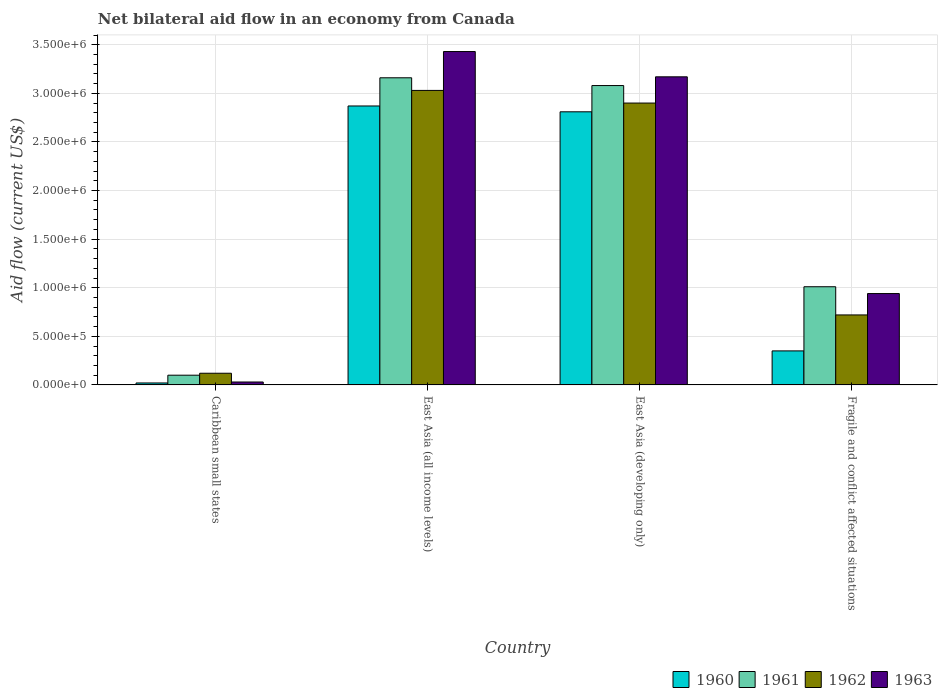How many groups of bars are there?
Offer a very short reply. 4. Are the number of bars per tick equal to the number of legend labels?
Make the answer very short. Yes. Are the number of bars on each tick of the X-axis equal?
Your answer should be compact. Yes. What is the label of the 2nd group of bars from the left?
Keep it short and to the point. East Asia (all income levels). What is the net bilateral aid flow in 1961 in East Asia (all income levels)?
Keep it short and to the point. 3.16e+06. Across all countries, what is the maximum net bilateral aid flow in 1963?
Your answer should be compact. 3.43e+06. Across all countries, what is the minimum net bilateral aid flow in 1963?
Your answer should be compact. 3.00e+04. In which country was the net bilateral aid flow in 1962 maximum?
Offer a very short reply. East Asia (all income levels). In which country was the net bilateral aid flow in 1963 minimum?
Offer a terse response. Caribbean small states. What is the total net bilateral aid flow in 1960 in the graph?
Ensure brevity in your answer.  6.05e+06. What is the difference between the net bilateral aid flow in 1961 in East Asia (all income levels) and that in Fragile and conflict affected situations?
Provide a short and direct response. 2.15e+06. What is the average net bilateral aid flow in 1962 per country?
Offer a very short reply. 1.69e+06. What is the difference between the net bilateral aid flow of/in 1963 and net bilateral aid flow of/in 1962 in Caribbean small states?
Your answer should be very brief. -9.00e+04. In how many countries, is the net bilateral aid flow in 1963 greater than 2400000 US$?
Keep it short and to the point. 2. What is the ratio of the net bilateral aid flow in 1960 in Caribbean small states to that in East Asia (developing only)?
Offer a very short reply. 0.01. Is the net bilateral aid flow in 1962 in Caribbean small states less than that in East Asia (all income levels)?
Provide a short and direct response. Yes. What is the difference between the highest and the second highest net bilateral aid flow in 1963?
Provide a succinct answer. 2.49e+06. What is the difference between the highest and the lowest net bilateral aid flow in 1960?
Make the answer very short. 2.85e+06. In how many countries, is the net bilateral aid flow in 1961 greater than the average net bilateral aid flow in 1961 taken over all countries?
Your answer should be very brief. 2. Is the sum of the net bilateral aid flow in 1961 in Caribbean small states and Fragile and conflict affected situations greater than the maximum net bilateral aid flow in 1962 across all countries?
Your answer should be very brief. No. Is it the case that in every country, the sum of the net bilateral aid flow in 1961 and net bilateral aid flow in 1962 is greater than the sum of net bilateral aid flow in 1960 and net bilateral aid flow in 1963?
Offer a terse response. No. What does the 3rd bar from the left in Caribbean small states represents?
Offer a terse response. 1962. What does the 1st bar from the right in Caribbean small states represents?
Offer a very short reply. 1963. How many bars are there?
Offer a terse response. 16. Are all the bars in the graph horizontal?
Give a very brief answer. No. How many countries are there in the graph?
Keep it short and to the point. 4. What is the difference between two consecutive major ticks on the Y-axis?
Offer a terse response. 5.00e+05. Does the graph contain any zero values?
Offer a terse response. No. Does the graph contain grids?
Ensure brevity in your answer.  Yes. Where does the legend appear in the graph?
Your answer should be compact. Bottom right. How are the legend labels stacked?
Your answer should be very brief. Horizontal. What is the title of the graph?
Keep it short and to the point. Net bilateral aid flow in an economy from Canada. What is the label or title of the X-axis?
Give a very brief answer. Country. What is the Aid flow (current US$) of 1961 in Caribbean small states?
Ensure brevity in your answer.  1.00e+05. What is the Aid flow (current US$) in 1960 in East Asia (all income levels)?
Give a very brief answer. 2.87e+06. What is the Aid flow (current US$) of 1961 in East Asia (all income levels)?
Your answer should be very brief. 3.16e+06. What is the Aid flow (current US$) in 1962 in East Asia (all income levels)?
Ensure brevity in your answer.  3.03e+06. What is the Aid flow (current US$) of 1963 in East Asia (all income levels)?
Your answer should be very brief. 3.43e+06. What is the Aid flow (current US$) in 1960 in East Asia (developing only)?
Offer a very short reply. 2.81e+06. What is the Aid flow (current US$) of 1961 in East Asia (developing only)?
Your response must be concise. 3.08e+06. What is the Aid flow (current US$) in 1962 in East Asia (developing only)?
Offer a very short reply. 2.90e+06. What is the Aid flow (current US$) of 1963 in East Asia (developing only)?
Make the answer very short. 3.17e+06. What is the Aid flow (current US$) of 1960 in Fragile and conflict affected situations?
Offer a very short reply. 3.50e+05. What is the Aid flow (current US$) in 1961 in Fragile and conflict affected situations?
Your answer should be compact. 1.01e+06. What is the Aid flow (current US$) of 1962 in Fragile and conflict affected situations?
Ensure brevity in your answer.  7.20e+05. What is the Aid flow (current US$) of 1963 in Fragile and conflict affected situations?
Keep it short and to the point. 9.40e+05. Across all countries, what is the maximum Aid flow (current US$) in 1960?
Your response must be concise. 2.87e+06. Across all countries, what is the maximum Aid flow (current US$) of 1961?
Offer a terse response. 3.16e+06. Across all countries, what is the maximum Aid flow (current US$) of 1962?
Your answer should be very brief. 3.03e+06. Across all countries, what is the maximum Aid flow (current US$) of 1963?
Offer a very short reply. 3.43e+06. Across all countries, what is the minimum Aid flow (current US$) in 1961?
Your response must be concise. 1.00e+05. Across all countries, what is the minimum Aid flow (current US$) of 1962?
Your response must be concise. 1.20e+05. Across all countries, what is the minimum Aid flow (current US$) in 1963?
Offer a very short reply. 3.00e+04. What is the total Aid flow (current US$) in 1960 in the graph?
Offer a very short reply. 6.05e+06. What is the total Aid flow (current US$) in 1961 in the graph?
Make the answer very short. 7.35e+06. What is the total Aid flow (current US$) in 1962 in the graph?
Give a very brief answer. 6.77e+06. What is the total Aid flow (current US$) in 1963 in the graph?
Make the answer very short. 7.57e+06. What is the difference between the Aid flow (current US$) in 1960 in Caribbean small states and that in East Asia (all income levels)?
Provide a short and direct response. -2.85e+06. What is the difference between the Aid flow (current US$) of 1961 in Caribbean small states and that in East Asia (all income levels)?
Keep it short and to the point. -3.06e+06. What is the difference between the Aid flow (current US$) of 1962 in Caribbean small states and that in East Asia (all income levels)?
Give a very brief answer. -2.91e+06. What is the difference between the Aid flow (current US$) in 1963 in Caribbean small states and that in East Asia (all income levels)?
Offer a terse response. -3.40e+06. What is the difference between the Aid flow (current US$) of 1960 in Caribbean small states and that in East Asia (developing only)?
Your answer should be very brief. -2.79e+06. What is the difference between the Aid flow (current US$) of 1961 in Caribbean small states and that in East Asia (developing only)?
Offer a terse response. -2.98e+06. What is the difference between the Aid flow (current US$) of 1962 in Caribbean small states and that in East Asia (developing only)?
Ensure brevity in your answer.  -2.78e+06. What is the difference between the Aid flow (current US$) in 1963 in Caribbean small states and that in East Asia (developing only)?
Make the answer very short. -3.14e+06. What is the difference between the Aid flow (current US$) in 1960 in Caribbean small states and that in Fragile and conflict affected situations?
Ensure brevity in your answer.  -3.30e+05. What is the difference between the Aid flow (current US$) in 1961 in Caribbean small states and that in Fragile and conflict affected situations?
Offer a very short reply. -9.10e+05. What is the difference between the Aid flow (current US$) in 1962 in Caribbean small states and that in Fragile and conflict affected situations?
Ensure brevity in your answer.  -6.00e+05. What is the difference between the Aid flow (current US$) of 1963 in Caribbean small states and that in Fragile and conflict affected situations?
Offer a terse response. -9.10e+05. What is the difference between the Aid flow (current US$) of 1962 in East Asia (all income levels) and that in East Asia (developing only)?
Ensure brevity in your answer.  1.30e+05. What is the difference between the Aid flow (current US$) of 1963 in East Asia (all income levels) and that in East Asia (developing only)?
Give a very brief answer. 2.60e+05. What is the difference between the Aid flow (current US$) of 1960 in East Asia (all income levels) and that in Fragile and conflict affected situations?
Offer a very short reply. 2.52e+06. What is the difference between the Aid flow (current US$) of 1961 in East Asia (all income levels) and that in Fragile and conflict affected situations?
Provide a succinct answer. 2.15e+06. What is the difference between the Aid flow (current US$) in 1962 in East Asia (all income levels) and that in Fragile and conflict affected situations?
Your answer should be very brief. 2.31e+06. What is the difference between the Aid flow (current US$) in 1963 in East Asia (all income levels) and that in Fragile and conflict affected situations?
Give a very brief answer. 2.49e+06. What is the difference between the Aid flow (current US$) in 1960 in East Asia (developing only) and that in Fragile and conflict affected situations?
Your response must be concise. 2.46e+06. What is the difference between the Aid flow (current US$) in 1961 in East Asia (developing only) and that in Fragile and conflict affected situations?
Ensure brevity in your answer.  2.07e+06. What is the difference between the Aid flow (current US$) of 1962 in East Asia (developing only) and that in Fragile and conflict affected situations?
Provide a succinct answer. 2.18e+06. What is the difference between the Aid flow (current US$) in 1963 in East Asia (developing only) and that in Fragile and conflict affected situations?
Your answer should be very brief. 2.23e+06. What is the difference between the Aid flow (current US$) of 1960 in Caribbean small states and the Aid flow (current US$) of 1961 in East Asia (all income levels)?
Provide a short and direct response. -3.14e+06. What is the difference between the Aid flow (current US$) of 1960 in Caribbean small states and the Aid flow (current US$) of 1962 in East Asia (all income levels)?
Offer a very short reply. -3.01e+06. What is the difference between the Aid flow (current US$) of 1960 in Caribbean small states and the Aid flow (current US$) of 1963 in East Asia (all income levels)?
Offer a terse response. -3.41e+06. What is the difference between the Aid flow (current US$) of 1961 in Caribbean small states and the Aid flow (current US$) of 1962 in East Asia (all income levels)?
Provide a short and direct response. -2.93e+06. What is the difference between the Aid flow (current US$) in 1961 in Caribbean small states and the Aid flow (current US$) in 1963 in East Asia (all income levels)?
Make the answer very short. -3.33e+06. What is the difference between the Aid flow (current US$) of 1962 in Caribbean small states and the Aid flow (current US$) of 1963 in East Asia (all income levels)?
Offer a very short reply. -3.31e+06. What is the difference between the Aid flow (current US$) of 1960 in Caribbean small states and the Aid flow (current US$) of 1961 in East Asia (developing only)?
Make the answer very short. -3.06e+06. What is the difference between the Aid flow (current US$) of 1960 in Caribbean small states and the Aid flow (current US$) of 1962 in East Asia (developing only)?
Make the answer very short. -2.88e+06. What is the difference between the Aid flow (current US$) in 1960 in Caribbean small states and the Aid flow (current US$) in 1963 in East Asia (developing only)?
Offer a terse response. -3.15e+06. What is the difference between the Aid flow (current US$) in 1961 in Caribbean small states and the Aid flow (current US$) in 1962 in East Asia (developing only)?
Your response must be concise. -2.80e+06. What is the difference between the Aid flow (current US$) of 1961 in Caribbean small states and the Aid flow (current US$) of 1963 in East Asia (developing only)?
Ensure brevity in your answer.  -3.07e+06. What is the difference between the Aid flow (current US$) of 1962 in Caribbean small states and the Aid flow (current US$) of 1963 in East Asia (developing only)?
Offer a terse response. -3.05e+06. What is the difference between the Aid flow (current US$) of 1960 in Caribbean small states and the Aid flow (current US$) of 1961 in Fragile and conflict affected situations?
Your answer should be very brief. -9.90e+05. What is the difference between the Aid flow (current US$) in 1960 in Caribbean small states and the Aid flow (current US$) in 1962 in Fragile and conflict affected situations?
Offer a terse response. -7.00e+05. What is the difference between the Aid flow (current US$) in 1960 in Caribbean small states and the Aid flow (current US$) in 1963 in Fragile and conflict affected situations?
Offer a very short reply. -9.20e+05. What is the difference between the Aid flow (current US$) of 1961 in Caribbean small states and the Aid flow (current US$) of 1962 in Fragile and conflict affected situations?
Your answer should be very brief. -6.20e+05. What is the difference between the Aid flow (current US$) of 1961 in Caribbean small states and the Aid flow (current US$) of 1963 in Fragile and conflict affected situations?
Offer a terse response. -8.40e+05. What is the difference between the Aid flow (current US$) of 1962 in Caribbean small states and the Aid flow (current US$) of 1963 in Fragile and conflict affected situations?
Your answer should be very brief. -8.20e+05. What is the difference between the Aid flow (current US$) of 1960 in East Asia (all income levels) and the Aid flow (current US$) of 1963 in East Asia (developing only)?
Give a very brief answer. -3.00e+05. What is the difference between the Aid flow (current US$) of 1961 in East Asia (all income levels) and the Aid flow (current US$) of 1963 in East Asia (developing only)?
Offer a very short reply. -10000. What is the difference between the Aid flow (current US$) in 1962 in East Asia (all income levels) and the Aid flow (current US$) in 1963 in East Asia (developing only)?
Give a very brief answer. -1.40e+05. What is the difference between the Aid flow (current US$) of 1960 in East Asia (all income levels) and the Aid flow (current US$) of 1961 in Fragile and conflict affected situations?
Your response must be concise. 1.86e+06. What is the difference between the Aid flow (current US$) of 1960 in East Asia (all income levels) and the Aid flow (current US$) of 1962 in Fragile and conflict affected situations?
Ensure brevity in your answer.  2.15e+06. What is the difference between the Aid flow (current US$) in 1960 in East Asia (all income levels) and the Aid flow (current US$) in 1963 in Fragile and conflict affected situations?
Your answer should be compact. 1.93e+06. What is the difference between the Aid flow (current US$) of 1961 in East Asia (all income levels) and the Aid flow (current US$) of 1962 in Fragile and conflict affected situations?
Make the answer very short. 2.44e+06. What is the difference between the Aid flow (current US$) of 1961 in East Asia (all income levels) and the Aid flow (current US$) of 1963 in Fragile and conflict affected situations?
Your response must be concise. 2.22e+06. What is the difference between the Aid flow (current US$) in 1962 in East Asia (all income levels) and the Aid flow (current US$) in 1963 in Fragile and conflict affected situations?
Offer a very short reply. 2.09e+06. What is the difference between the Aid flow (current US$) in 1960 in East Asia (developing only) and the Aid flow (current US$) in 1961 in Fragile and conflict affected situations?
Keep it short and to the point. 1.80e+06. What is the difference between the Aid flow (current US$) of 1960 in East Asia (developing only) and the Aid flow (current US$) of 1962 in Fragile and conflict affected situations?
Make the answer very short. 2.09e+06. What is the difference between the Aid flow (current US$) in 1960 in East Asia (developing only) and the Aid flow (current US$) in 1963 in Fragile and conflict affected situations?
Your answer should be compact. 1.87e+06. What is the difference between the Aid flow (current US$) in 1961 in East Asia (developing only) and the Aid flow (current US$) in 1962 in Fragile and conflict affected situations?
Offer a terse response. 2.36e+06. What is the difference between the Aid flow (current US$) in 1961 in East Asia (developing only) and the Aid flow (current US$) in 1963 in Fragile and conflict affected situations?
Give a very brief answer. 2.14e+06. What is the difference between the Aid flow (current US$) in 1962 in East Asia (developing only) and the Aid flow (current US$) in 1963 in Fragile and conflict affected situations?
Keep it short and to the point. 1.96e+06. What is the average Aid flow (current US$) in 1960 per country?
Ensure brevity in your answer.  1.51e+06. What is the average Aid flow (current US$) of 1961 per country?
Your response must be concise. 1.84e+06. What is the average Aid flow (current US$) of 1962 per country?
Give a very brief answer. 1.69e+06. What is the average Aid flow (current US$) in 1963 per country?
Keep it short and to the point. 1.89e+06. What is the difference between the Aid flow (current US$) of 1960 and Aid flow (current US$) of 1961 in Caribbean small states?
Keep it short and to the point. -8.00e+04. What is the difference between the Aid flow (current US$) of 1960 and Aid flow (current US$) of 1962 in Caribbean small states?
Provide a succinct answer. -1.00e+05. What is the difference between the Aid flow (current US$) in 1960 and Aid flow (current US$) in 1963 in East Asia (all income levels)?
Offer a terse response. -5.60e+05. What is the difference between the Aid flow (current US$) in 1961 and Aid flow (current US$) in 1962 in East Asia (all income levels)?
Your response must be concise. 1.30e+05. What is the difference between the Aid flow (current US$) in 1962 and Aid flow (current US$) in 1963 in East Asia (all income levels)?
Make the answer very short. -4.00e+05. What is the difference between the Aid flow (current US$) of 1960 and Aid flow (current US$) of 1961 in East Asia (developing only)?
Provide a succinct answer. -2.70e+05. What is the difference between the Aid flow (current US$) of 1960 and Aid flow (current US$) of 1963 in East Asia (developing only)?
Give a very brief answer. -3.60e+05. What is the difference between the Aid flow (current US$) of 1960 and Aid flow (current US$) of 1961 in Fragile and conflict affected situations?
Give a very brief answer. -6.60e+05. What is the difference between the Aid flow (current US$) in 1960 and Aid flow (current US$) in 1962 in Fragile and conflict affected situations?
Your answer should be compact. -3.70e+05. What is the difference between the Aid flow (current US$) of 1960 and Aid flow (current US$) of 1963 in Fragile and conflict affected situations?
Ensure brevity in your answer.  -5.90e+05. What is the difference between the Aid flow (current US$) of 1961 and Aid flow (current US$) of 1962 in Fragile and conflict affected situations?
Provide a short and direct response. 2.90e+05. What is the ratio of the Aid flow (current US$) in 1960 in Caribbean small states to that in East Asia (all income levels)?
Give a very brief answer. 0.01. What is the ratio of the Aid flow (current US$) in 1961 in Caribbean small states to that in East Asia (all income levels)?
Provide a succinct answer. 0.03. What is the ratio of the Aid flow (current US$) of 1962 in Caribbean small states to that in East Asia (all income levels)?
Keep it short and to the point. 0.04. What is the ratio of the Aid flow (current US$) in 1963 in Caribbean small states to that in East Asia (all income levels)?
Your response must be concise. 0.01. What is the ratio of the Aid flow (current US$) of 1960 in Caribbean small states to that in East Asia (developing only)?
Your answer should be compact. 0.01. What is the ratio of the Aid flow (current US$) in 1961 in Caribbean small states to that in East Asia (developing only)?
Your answer should be compact. 0.03. What is the ratio of the Aid flow (current US$) in 1962 in Caribbean small states to that in East Asia (developing only)?
Give a very brief answer. 0.04. What is the ratio of the Aid flow (current US$) of 1963 in Caribbean small states to that in East Asia (developing only)?
Your answer should be very brief. 0.01. What is the ratio of the Aid flow (current US$) of 1960 in Caribbean small states to that in Fragile and conflict affected situations?
Offer a very short reply. 0.06. What is the ratio of the Aid flow (current US$) of 1961 in Caribbean small states to that in Fragile and conflict affected situations?
Offer a very short reply. 0.1. What is the ratio of the Aid flow (current US$) in 1963 in Caribbean small states to that in Fragile and conflict affected situations?
Make the answer very short. 0.03. What is the ratio of the Aid flow (current US$) in 1960 in East Asia (all income levels) to that in East Asia (developing only)?
Your response must be concise. 1.02. What is the ratio of the Aid flow (current US$) of 1962 in East Asia (all income levels) to that in East Asia (developing only)?
Make the answer very short. 1.04. What is the ratio of the Aid flow (current US$) of 1963 in East Asia (all income levels) to that in East Asia (developing only)?
Your answer should be very brief. 1.08. What is the ratio of the Aid flow (current US$) of 1961 in East Asia (all income levels) to that in Fragile and conflict affected situations?
Your answer should be very brief. 3.13. What is the ratio of the Aid flow (current US$) of 1962 in East Asia (all income levels) to that in Fragile and conflict affected situations?
Offer a very short reply. 4.21. What is the ratio of the Aid flow (current US$) in 1963 in East Asia (all income levels) to that in Fragile and conflict affected situations?
Offer a very short reply. 3.65. What is the ratio of the Aid flow (current US$) in 1960 in East Asia (developing only) to that in Fragile and conflict affected situations?
Provide a short and direct response. 8.03. What is the ratio of the Aid flow (current US$) of 1961 in East Asia (developing only) to that in Fragile and conflict affected situations?
Give a very brief answer. 3.05. What is the ratio of the Aid flow (current US$) in 1962 in East Asia (developing only) to that in Fragile and conflict affected situations?
Ensure brevity in your answer.  4.03. What is the ratio of the Aid flow (current US$) of 1963 in East Asia (developing only) to that in Fragile and conflict affected situations?
Your response must be concise. 3.37. What is the difference between the highest and the second highest Aid flow (current US$) of 1960?
Provide a short and direct response. 6.00e+04. What is the difference between the highest and the lowest Aid flow (current US$) of 1960?
Your response must be concise. 2.85e+06. What is the difference between the highest and the lowest Aid flow (current US$) in 1961?
Offer a terse response. 3.06e+06. What is the difference between the highest and the lowest Aid flow (current US$) of 1962?
Offer a terse response. 2.91e+06. What is the difference between the highest and the lowest Aid flow (current US$) in 1963?
Make the answer very short. 3.40e+06. 